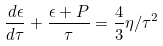Convert formula to latex. <formula><loc_0><loc_0><loc_500><loc_500>\frac { d \epsilon } { d \tau } + \frac { \epsilon + P } { \tau } = \frac { 4 } { 3 } \eta / \tau ^ { 2 }</formula> 